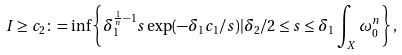Convert formula to latex. <formula><loc_0><loc_0><loc_500><loc_500>I \geq c _ { 2 } \colon = \inf \left \{ \delta _ { 1 } ^ { \frac { 1 } { n } - 1 } s \exp ( - \delta _ { 1 } c _ { 1 } / s ) | \delta _ { 2 } / 2 \leq s \leq \delta _ { 1 } \int _ { X } \omega _ { 0 } ^ { n } \right \} ,</formula> 